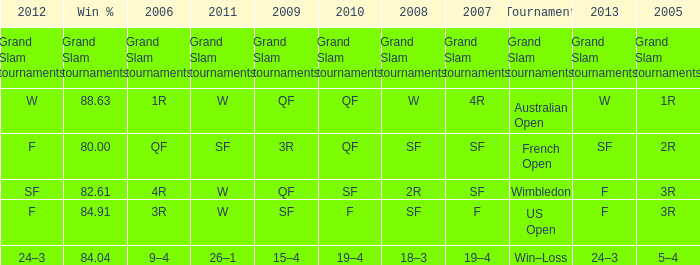What in 2007 has a 2008 of sf, and a 2010 of f? F. 